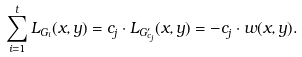<formula> <loc_0><loc_0><loc_500><loc_500>\sum _ { i = 1 } ^ { t } L _ { G _ { i } } ( x , y ) = c _ { j } \cdot L _ { G _ { c _ { j } } ^ { \prime } } ( x , y ) = - c _ { j } \cdot w ( x , y ) .</formula> 